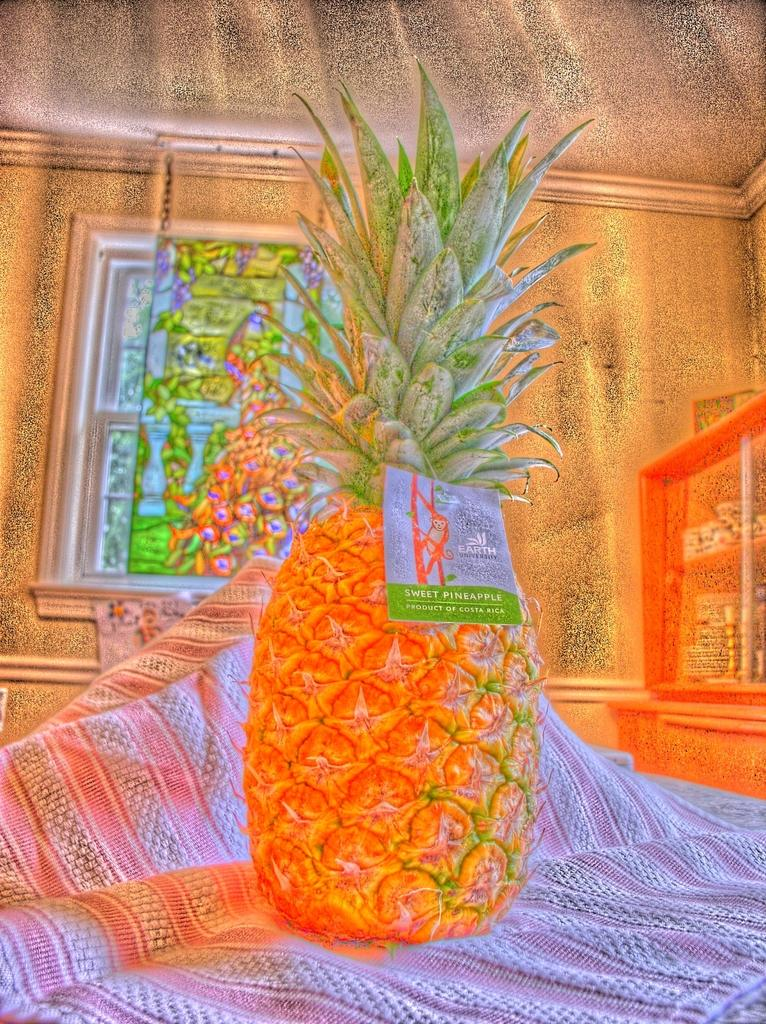What type of image is being described? The image is animated. What object is placed on a cloth in the image? There is a pineapple on a cloth in the image. What type of structure can be seen in the background of the image? There is a wall visible in the image. What architectural feature allows light and air into the room in the image? There is a window in the image. How many shelves are visible in the image? There are no shelves present in the image. What type of bears can be seen interacting with the pineapple in the image? There are no bears present in the image; it features a pineapple on a cloth. What type of deer is visible through the window in the image? There are no deer visible through the window in the image. 